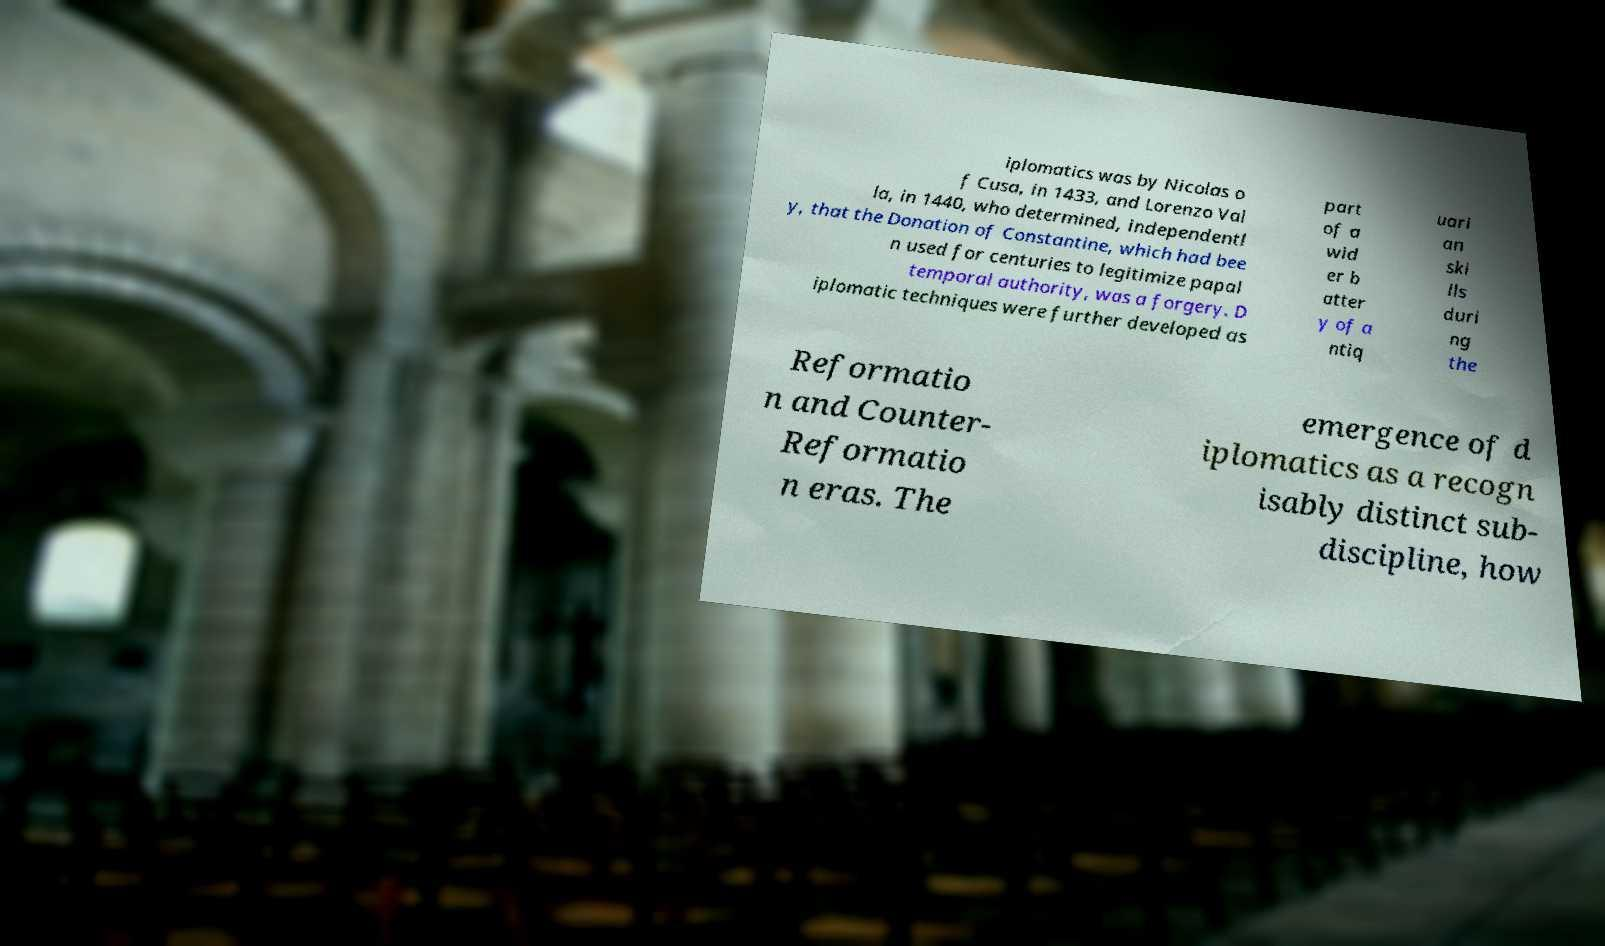Could you extract and type out the text from this image? iplomatics was by Nicolas o f Cusa, in 1433, and Lorenzo Val la, in 1440, who determined, independentl y, that the Donation of Constantine, which had bee n used for centuries to legitimize papal temporal authority, was a forgery. D iplomatic techniques were further developed as part of a wid er b atter y of a ntiq uari an ski lls duri ng the Reformatio n and Counter- Reformatio n eras. The emergence of d iplomatics as a recogn isably distinct sub- discipline, how 